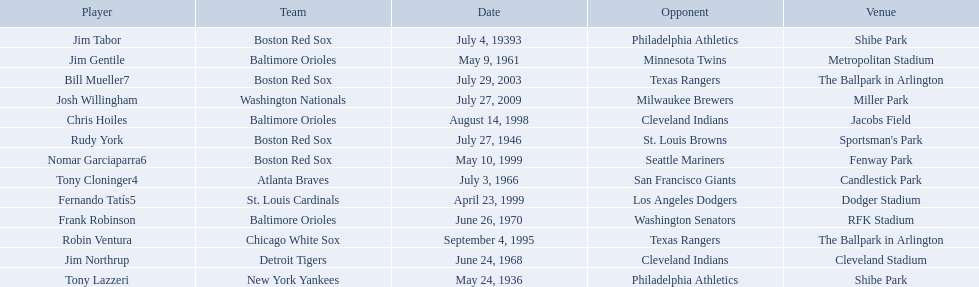What are the dates? May 24, 1936, July 4, 19393, July 27, 1946, May 9, 1961, July 3, 1966, June 24, 1968, June 26, 1970, September 4, 1995, August 14, 1998, April 23, 1999, May 10, 1999, July 29, 2003, July 27, 2009. Which date is in 1936? May 24, 1936. What player is listed for this date? Tony Lazzeri. 